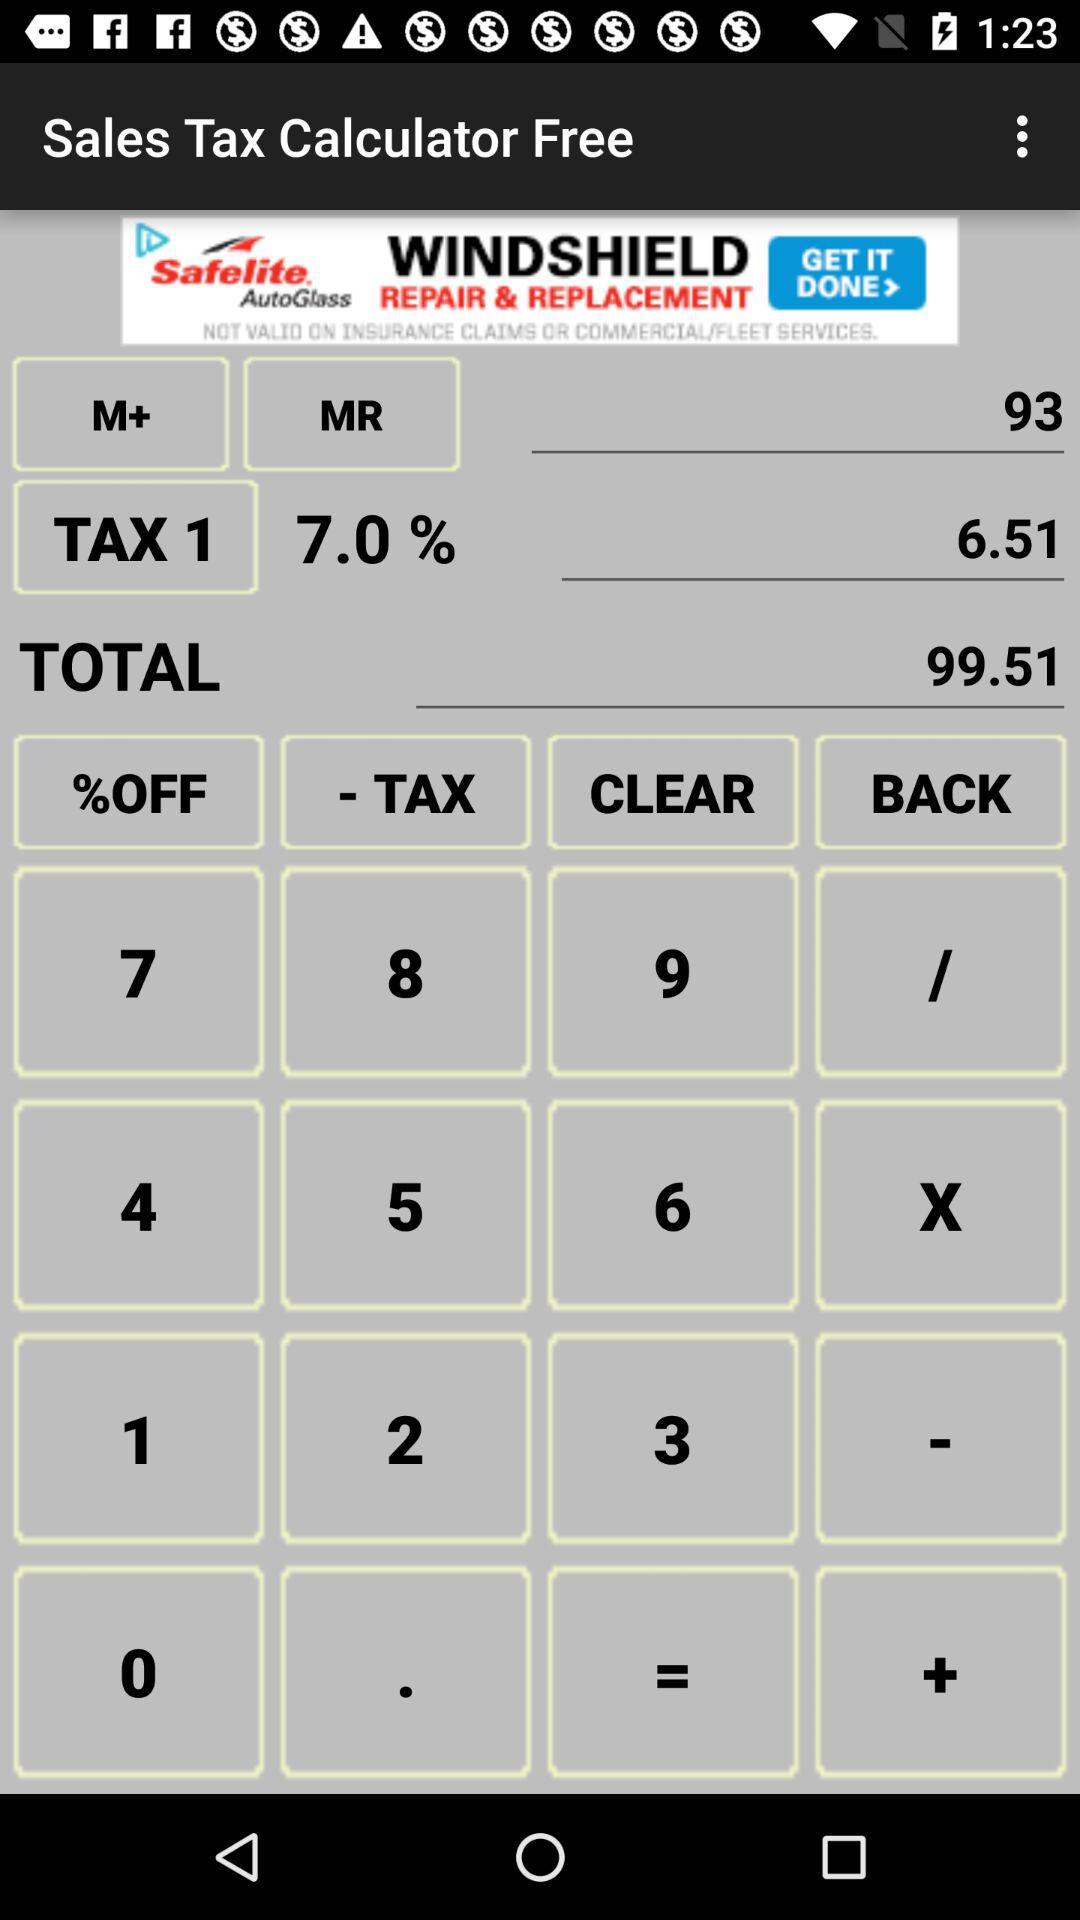What is the total amount? The total amount is 99.51. 